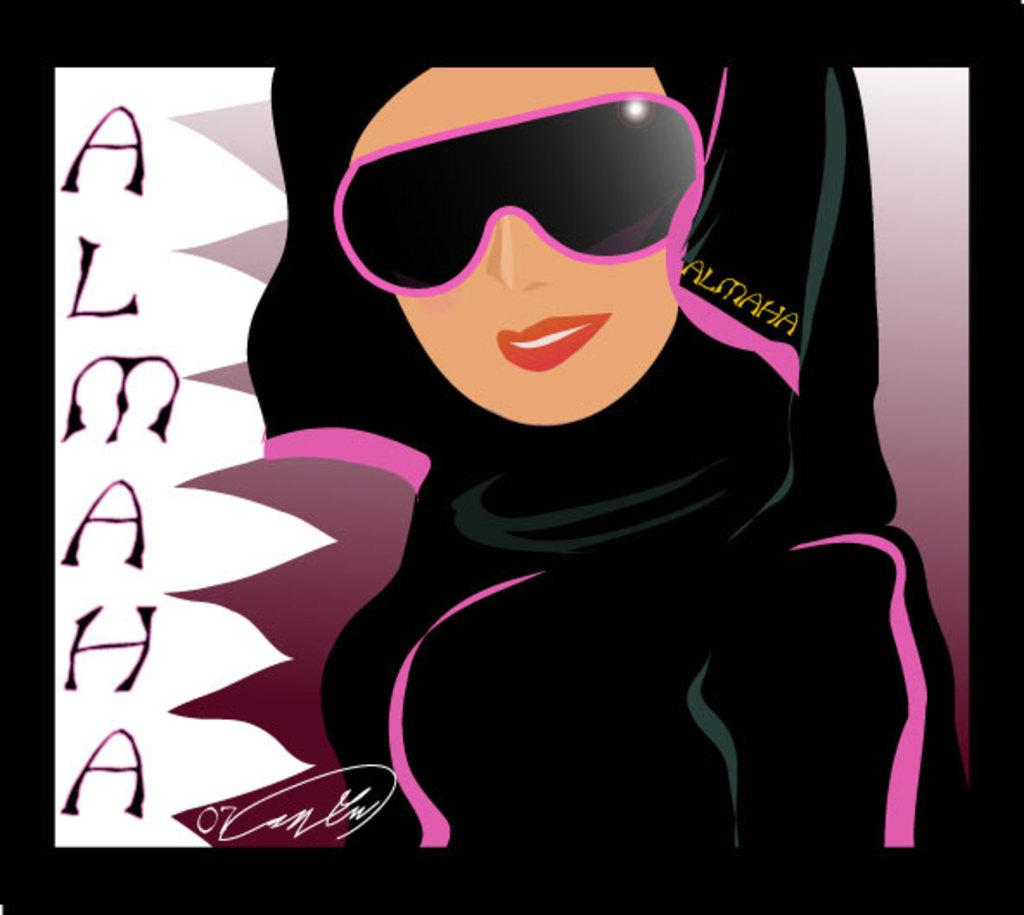What is the main subject of the digital art? The main subject of the digital art is a woman. What is the woman wearing in the image? The woman is wearing a black and pink colored dress and black and pink colored goggles. What expression does the woman have in the image? The woman is smiling in the image. Can you describe the earthquake happening in the background of the image? There is no earthquake present in the image; it features a woman wearing a black and pink colored dress and goggles, and smiling. What type of bird is the woman holding in the image? There is no bird present in the image; it features a woman wearing a black and pink colored dress and goggles, and smiling. 